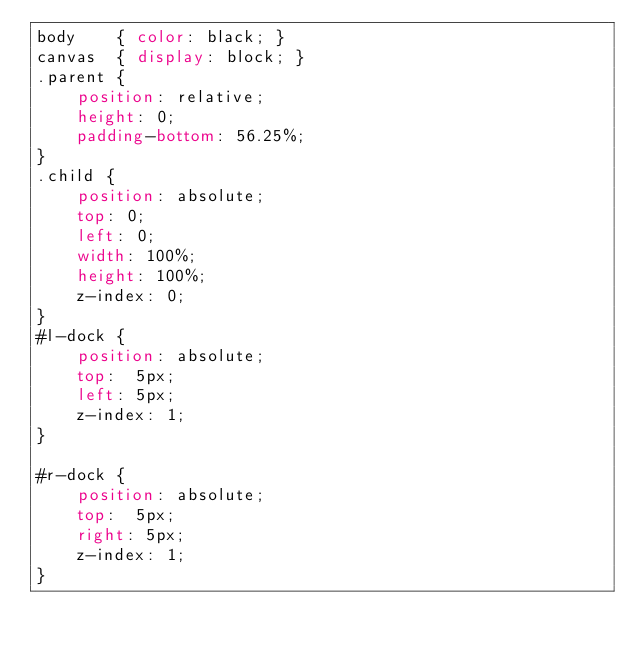<code> <loc_0><loc_0><loc_500><loc_500><_CSS_>body    { color: black; }
canvas  { display: block; }
.parent {
    position: relative;
    height: 0;
    padding-bottom: 56.25%;
}
.child {
    position: absolute;
    top: 0;
    left: 0;
    width: 100%;
    height: 100%;
    z-index: 0;
}
#l-dock {
    position: absolute;
    top:  5px;
    left: 5px;
    z-index: 1;
}

#r-dock {
    position: absolute;
    top:  5px;
    right: 5px;
    z-index: 1;
}

</code> 